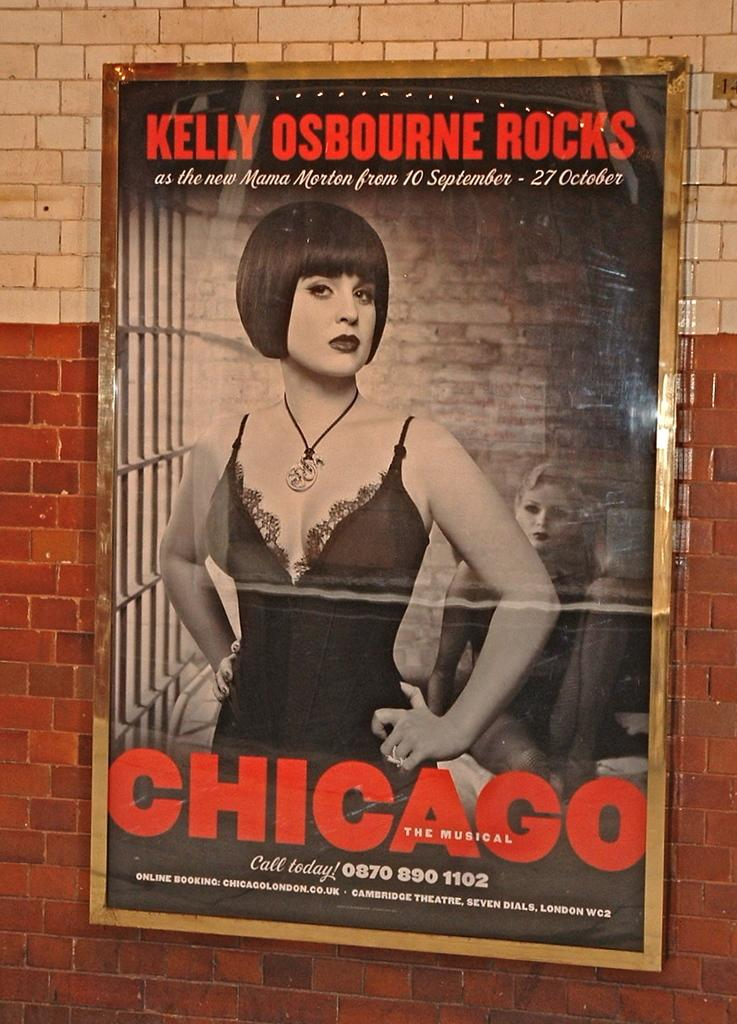Provide a one-sentence caption for the provided image. A poster for the musical CHICAGO starring Kelly Osbourne as the new Mama Morton from 10 September - 27 October. 